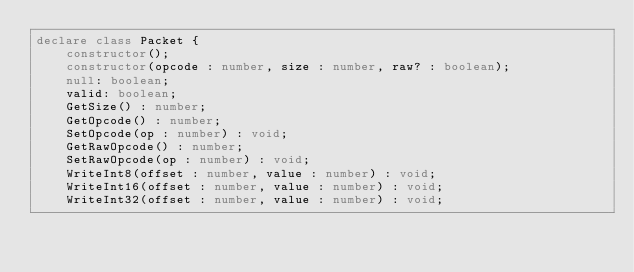Convert code to text. <code><loc_0><loc_0><loc_500><loc_500><_TypeScript_>declare class Packet {
    constructor();
    constructor(opcode : number, size : number, raw? : boolean);
    null: boolean;
    valid: boolean;
    GetSize() : number;
    GetOpcode() : number;
    SetOpcode(op : number) : void;
    GetRawOpcode() : number;
    SetRawOpcode(op : number) : void;
    WriteInt8(offset : number, value : number) : void;
    WriteInt16(offset : number, value : number) : void;
    WriteInt32(offset : number, value : number) : void;</code> 